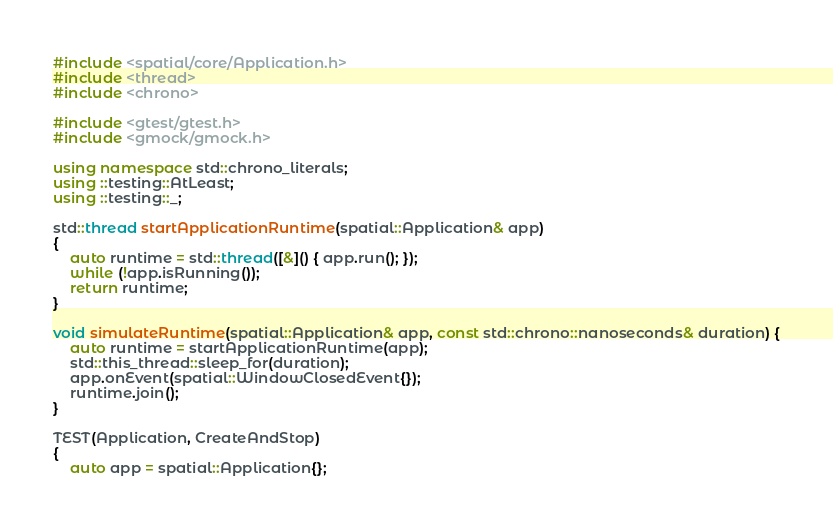<code> <loc_0><loc_0><loc_500><loc_500><_C++_>#include <spatial/core/Application.h>
#include <thread>
#include <chrono>

#include <gtest/gtest.h>
#include <gmock/gmock.h>

using namespace std::chrono_literals;
using ::testing::AtLeast;
using ::testing::_;

std::thread startApplicationRuntime(spatial::Application& app)
{
	auto runtime = std::thread([&]() { app.run(); });
	while (!app.isRunning());
	return runtime;
}

void simulateRuntime(spatial::Application& app, const std::chrono::nanoseconds& duration) {
	auto runtime = startApplicationRuntime(app);
	std::this_thread::sleep_for(duration);
	app.onEvent(spatial::WindowClosedEvent{});
	runtime.join();
}

TEST(Application, CreateAndStop)
{
	auto app = spatial::Application{};</code> 